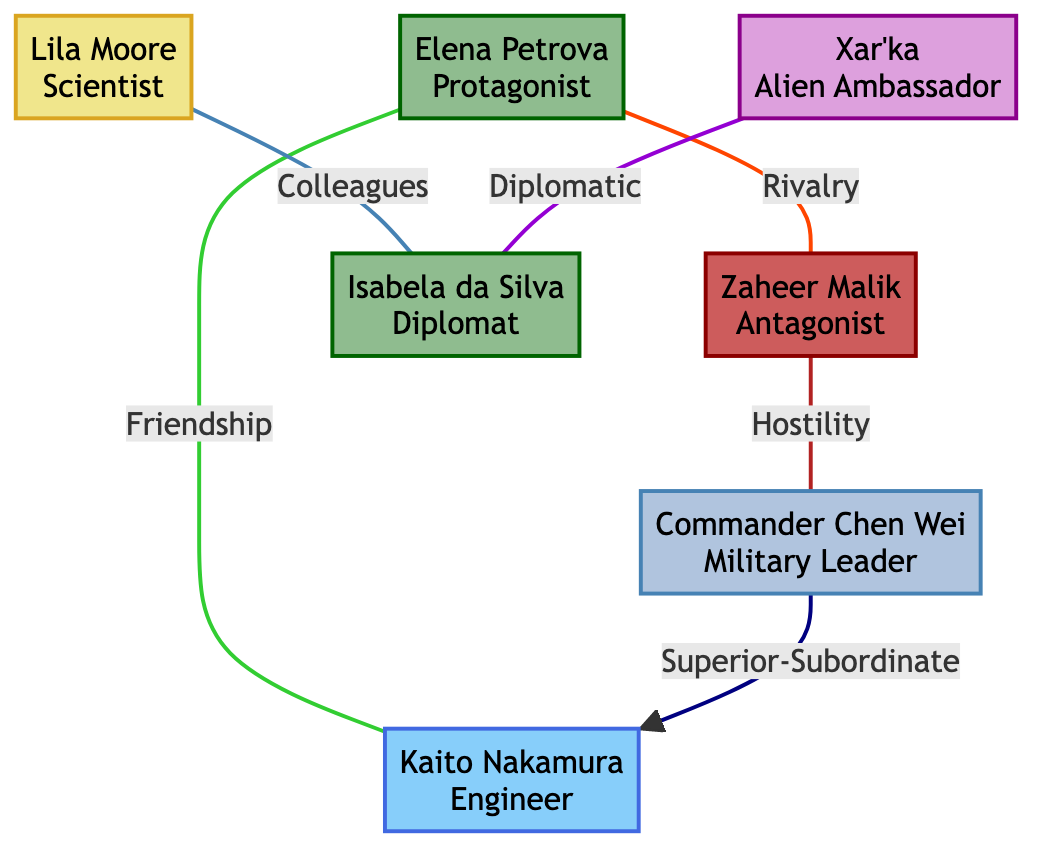What is the role of Elena Petrova? The diagram identifies Elena Petrova as the Protagonist, which is explicitly stated next to her name in the node.
Answer: Protagonist How many characters are from Earth? By counting the nodes shaded with the Earth color, we see there are three characters: Elena Petrova, Isabela da Silva, and one more identified by the same color.
Answer: 3 What type of relationship exists between Kaito Nakamura and Commander Chen Wei? The diagram indicates that there is a "Superior-Subordinate" relationship directed from Commander Chen Wei to Kaito Nakamura, which is noted in the type of link connecting these two nodes.
Answer: Superior-Subordinate Who has a rivalry with Zaheer Malik? The diagram shows that Elena Petrova has a rivalry with Zaheer Malik, which is indicated by the link type labeled "Rivalry."
Answer: Elena Petrova What is the relationship type between Lila Moore and Isabela da Silva? The relationship is labeled as "Colleagues," which is written in the link connecting the two characters.
Answer: Colleagues Which character is associated with hostility towards Commander Chen Wei? The diagram indicates that Zaheer Malik exhibits hostility towards Commander Chen Wei, shown by the link labeled "Hostility."
Answer: Zaheer Malik How many characters have direct relationships with Kaito Nakamura? Examining the links originating from Kaito Nakamura shows that he has two direct relationships: one with Elena Petrova (Friendship) and the other with Commander Chen Wei (Superior-Subordinate).
Answer: 2 What role does Xar'ka play in relation to Isabela da Silva? Xar'ka is an Alien Ambassador and has a "Diplomatic" relationship with Isabela da Silva, as indicated by the relationship label linked to both characters.
Answer: Diplomatic Which character has an antagonistic role in the series? The diagram clearly labels Zaheer Malik as the Antagonist, shown next to his name in the corresponding node.
Answer: Zaheer Malik 